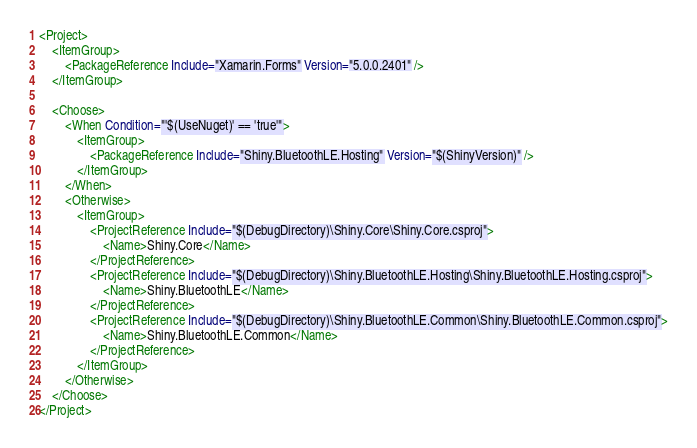Convert code to text. <code><loc_0><loc_0><loc_500><loc_500><_XML_><Project>
	<ItemGroup>
		<PackageReference Include="Xamarin.Forms" Version="5.0.0.2401" />
    </ItemGroup>

	<Choose>
		<When Condition="'$(UseNuget)' == 'true'">
			<ItemGroup>
				<PackageReference Include="Shiny.BluetoothLE.Hosting" Version="$(ShinyVersion)" />
			</ItemGroup>
		</When>
		<Otherwise>
			<ItemGroup>
				<ProjectReference Include="$(DebugDirectory)\Shiny.Core\Shiny.Core.csproj">
					<Name>Shiny.Core</Name>
				</ProjectReference>
				<ProjectReference Include="$(DebugDirectory)\Shiny.BluetoothLE.Hosting\Shiny.BluetoothLE.Hosting.csproj">
					<Name>Shiny.BluetoothLE</Name>
				</ProjectReference>
				<ProjectReference Include="$(DebugDirectory)\Shiny.BluetoothLE.Common\Shiny.BluetoothLE.Common.csproj">
					<Name>Shiny.BluetoothLE.Common</Name>
				</ProjectReference>
			</ItemGroup>
		</Otherwise>
	</Choose>
</Project></code> 